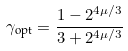Convert formula to latex. <formula><loc_0><loc_0><loc_500><loc_500>\gamma _ { \text {opt} } = \frac { 1 - 2 ^ { 4 \mu / 3 } } { 3 + 2 ^ { 4 \mu / 3 } }</formula> 